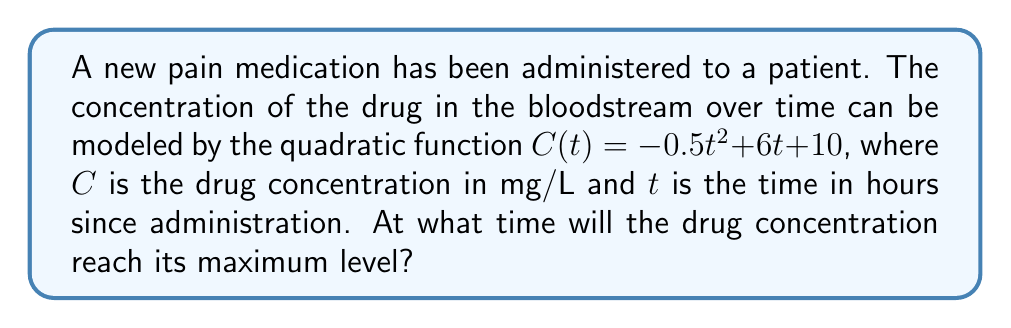Provide a solution to this math problem. To find the time when the drug concentration reaches its maximum level, we need to follow these steps:

1) The quadratic function is in the form $f(x) = ax^2 + bx + c$, where $a = -0.5$, $b = 6$, and $c = 10$.

2) For a quadratic function, the x-coordinate of the vertex represents the point where the function reaches its maximum (if $a < 0$) or minimum (if $a > 0$).

3) The formula for the x-coordinate of the vertex is $x = -\frac{b}{2a}$.

4) Substituting our values:

   $t = -\frac{6}{2(-0.5)} = -\frac{6}{-1} = 6$

5) Therefore, the drug concentration will reach its maximum level 6 hours after administration.

6) We can verify this by calculating the derivative of $C(t)$ and setting it to zero:

   $C'(t) = -t + 6$
   $0 = -t + 6$
   $t = 6$

This confirms our result.
Answer: 6 hours 